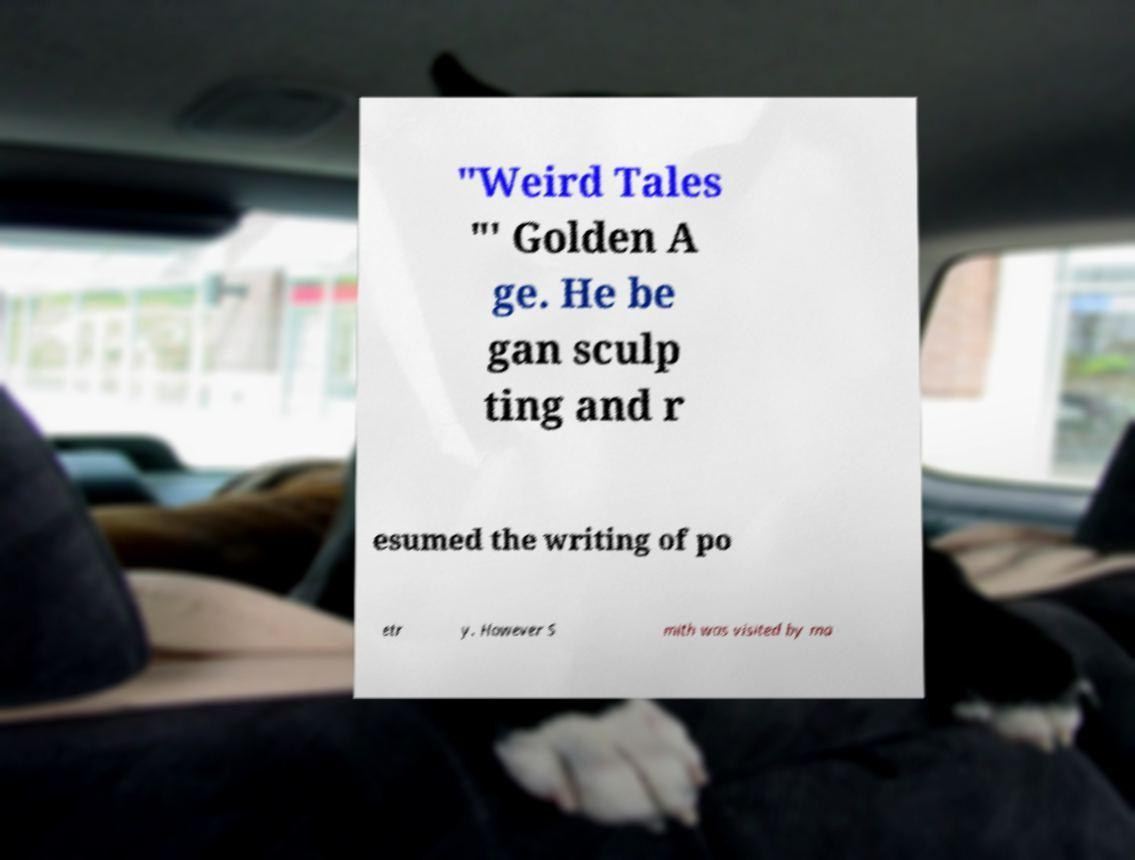Can you read and provide the text displayed in the image?This photo seems to have some interesting text. Can you extract and type it out for me? "Weird Tales "' Golden A ge. He be gan sculp ting and r esumed the writing of po etr y. However S mith was visited by ma 